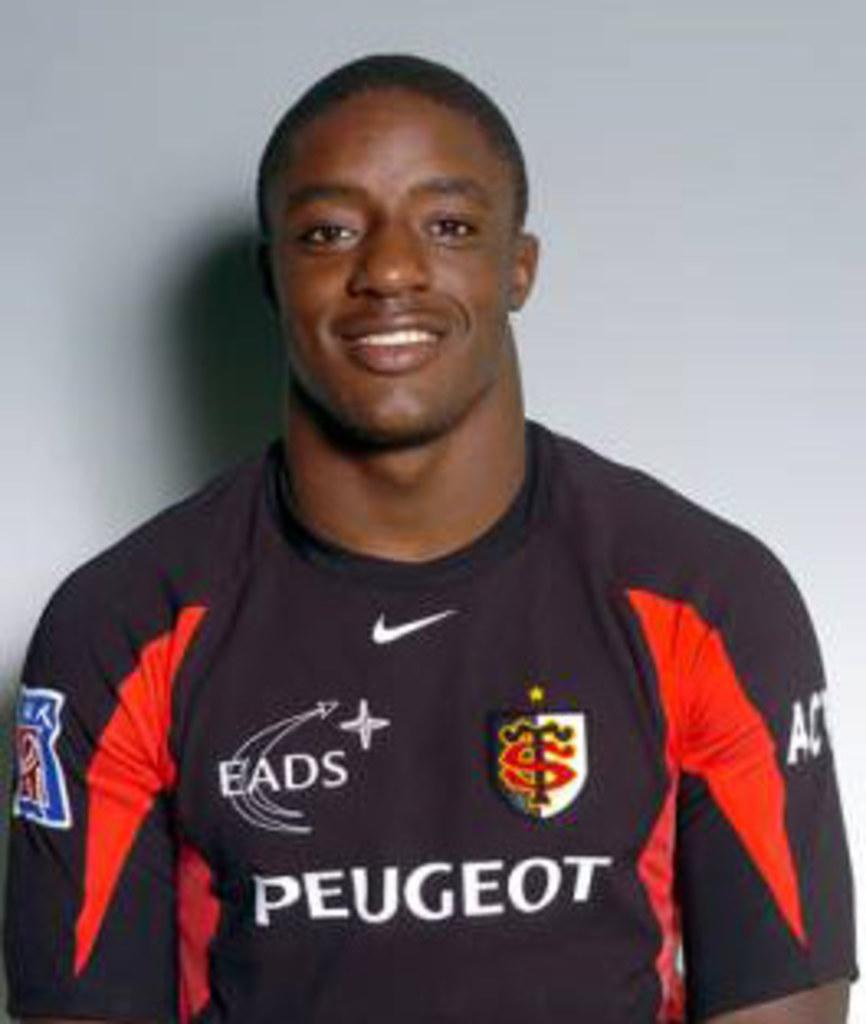<image>
Render a clear and concise summary of the photo. A man wearing a Peugeot jersey smiles for his picture. 